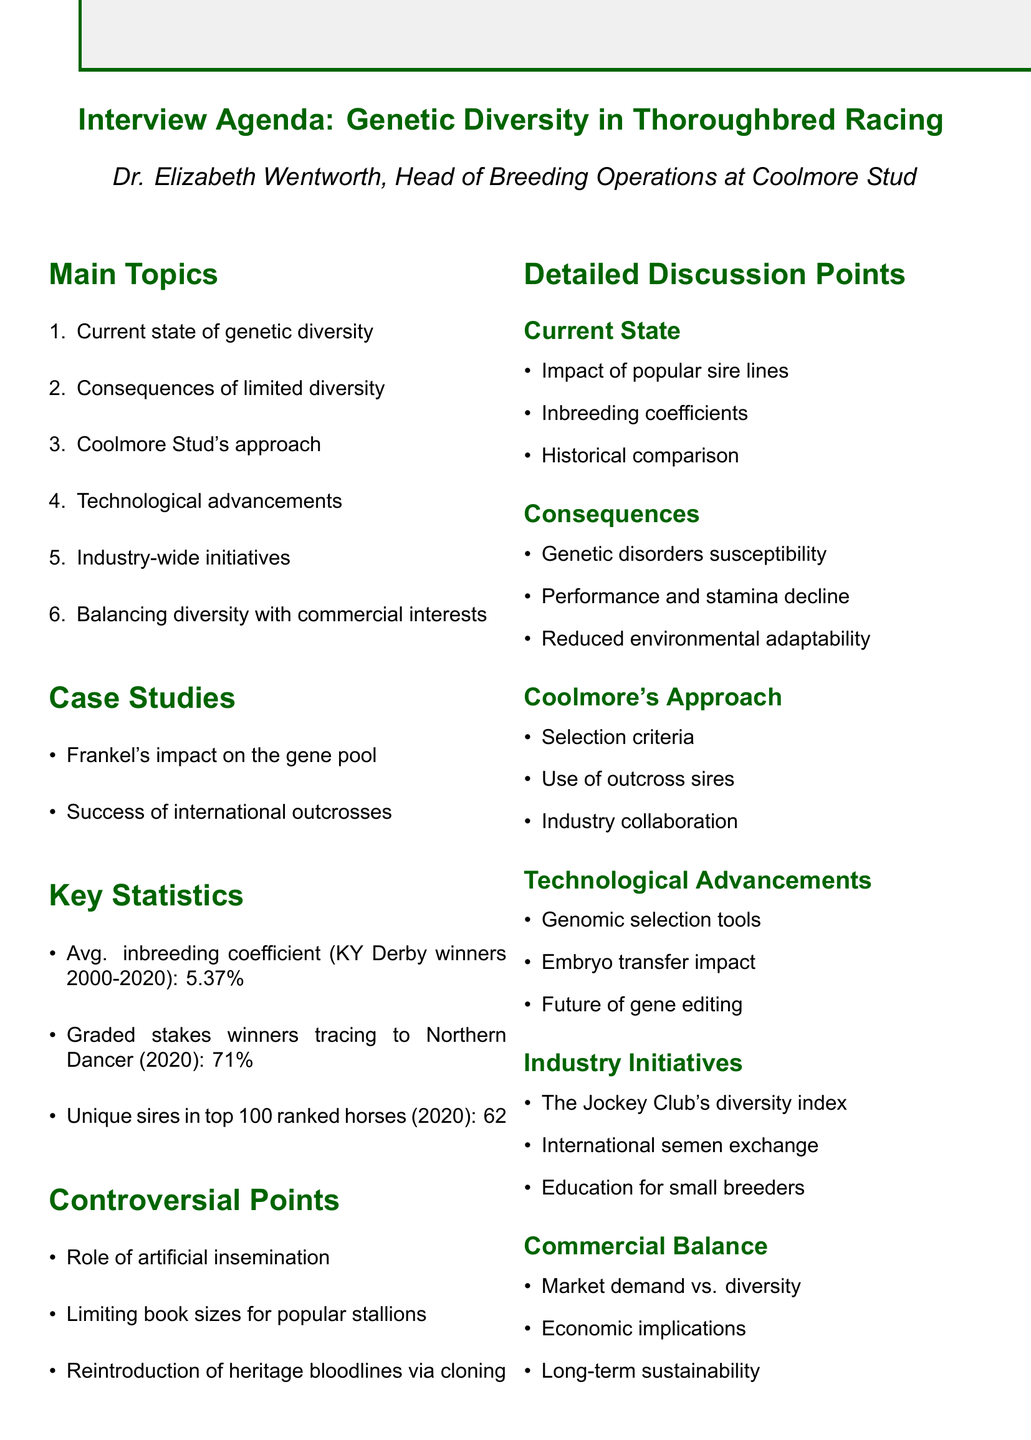What is Dr. Elizabeth Wentworth's position? Dr. Elizabeth Wentworth is identified as the Head of Breeding Operations at Coolmore Stud.
Answer: Head of Breeding Operations at Coolmore Stud What is the average inbreeding coefficient of Kentucky Derby winners from 2000 to 2020? The document states the average inbreeding coefficient for these winners is 5.37%.
Answer: 5.37% What percentage of graded stakes winners traced to Northern Dancer in 2020? The document specifies that 71% of graded stakes winners traced to Northern Dancer in 2020.
Answer: 71% What is one consequence of limited genetic diversity mentioned? The document lists increased susceptibility to genetic disorders as one consequence.
Answer: Increased susceptibility to genetic disorders What technological advancement is mentioned that could impact diversity? The document references genomic selection tools as a technological advancement related to breeding.
Answer: Genomic selection tools What industry-wide initiative is mentioned to address genetic diversity concerns? The Jockey Club's genetic diversity index is cited as an initiative in the document.
Answer: The Jockey Club's genetic diversity index Which case study examines the impact of Frankel on genetics? The document describes a case study titled "Frankel's impact on the gene pool."
Answer: Frankel's impact on the gene pool What is a controversial point related to stallion management? The limitation of book sizes for popular stallions is discussed as a controversial point.
Answer: Limiting book sizes for popular stallions What is the main focus of the agenda? The agenda focuses on genetic diversity in thoroughbred racing.
Answer: Genetic diversity in thoroughbred racing 